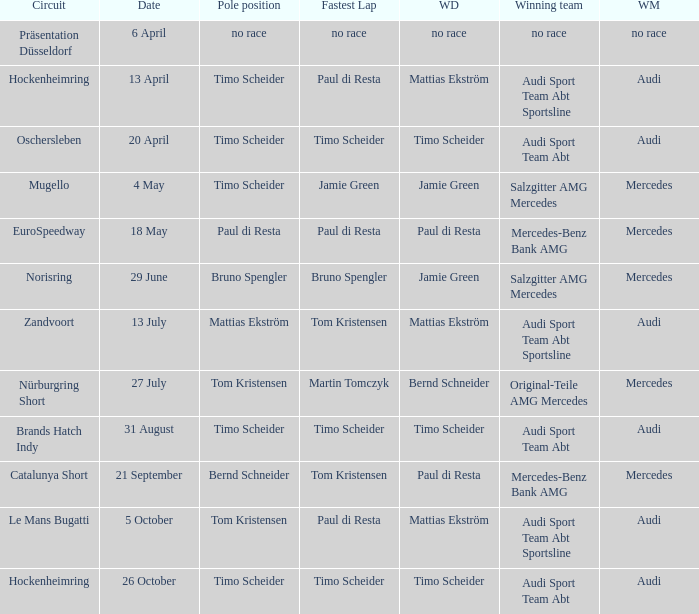Who is the winning driver of the Oschersleben circuit with Timo Scheider as the pole position? Timo Scheider. 